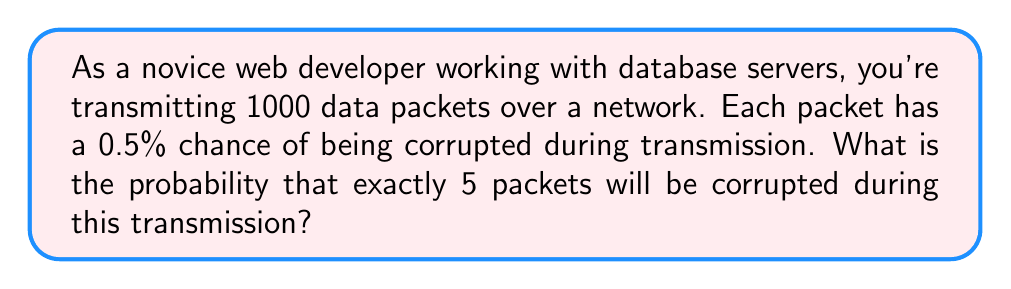Can you solve this math problem? To solve this problem, we'll use the binomial probability formula, as we're dealing with a fixed number of independent trials (data packet transmissions) with two possible outcomes (corrupted or not corrupted).

1. Identify the components of the binomial probability formula:
   $P(X = k) = \binom{n}{k} p^k (1-p)^{n-k}$
   
   Where:
   $n$ = number of trials (data packets) = 1000
   $k$ = number of successes (corrupted packets) = 5
   $p$ = probability of success (corruption) for each trial = 0.005 (0.5%)

2. Calculate the binomial coefficient:
   $\binom{n}{k} = \binom{1000}{5} = \frac{1000!}{5!(1000-5)!} = 8.25 \times 10^{12}$

3. Calculate $p^k$:
   $0.005^5 = 3.125 \times 10^{-13}$

4. Calculate $(1-p)^{n-k}$:
   $(1-0.005)^{1000-5} = 0.995^{995} \approx 0.0067$

5. Multiply all components:
   $P(X = 5) = 8.25 \times 10^{12} \times 3.125 \times 10^{-13} \times 0.0067 \approx 0.1631$

6. Convert to percentage:
   $0.1631 \times 100\% = 16.31\%$

Therefore, the probability of exactly 5 packets being corrupted during the transmission is approximately 16.31%.
Answer: 16.31% 